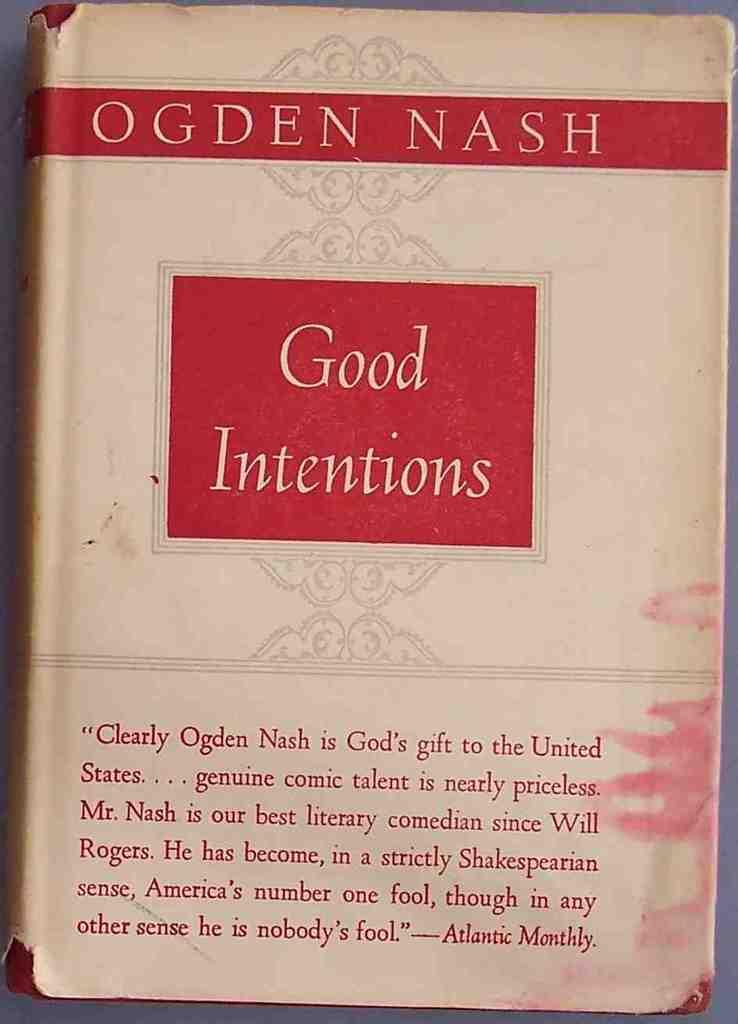<image>
Describe the image concisely. A tattered copy of the book Good Intentions by Ogden Nash. 